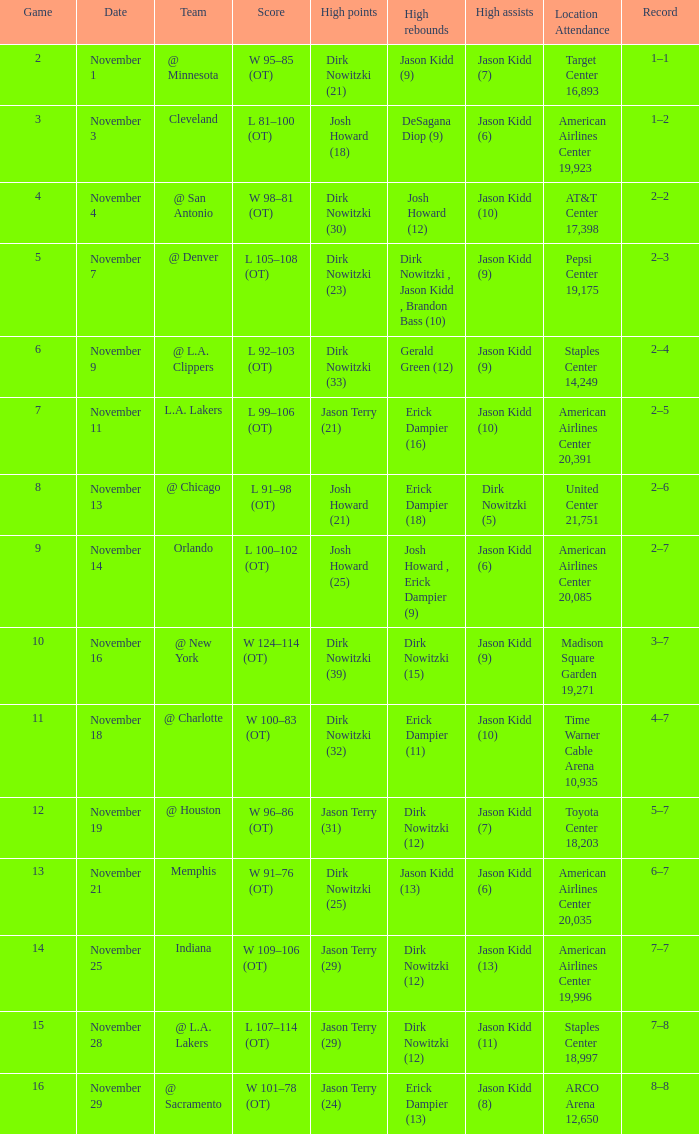What is the lowest Game, when Date is "November 1"? 2.0. 